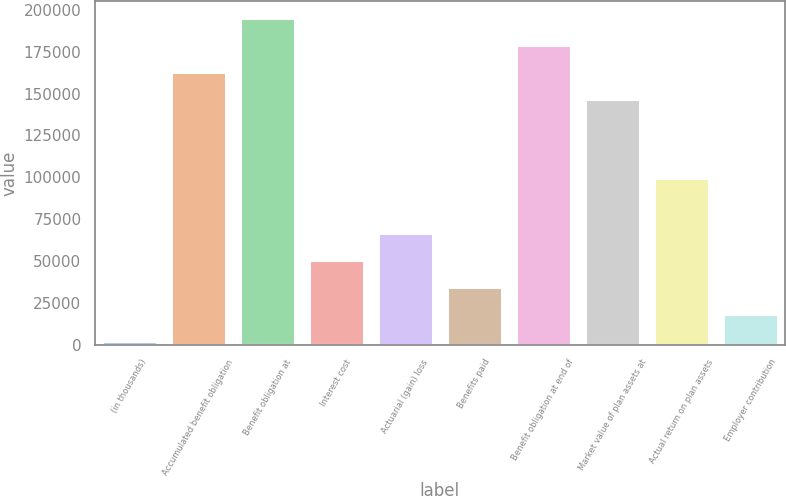Convert chart. <chart><loc_0><loc_0><loc_500><loc_500><bar_chart><fcel>(in thousands)<fcel>Accumulated benefit obligation<fcel>Benefit obligation at<fcel>Interest cost<fcel>Actuarial (gain) loss<fcel>Benefits paid<fcel>Benefit obligation at end of<fcel>Market value of plan assets at<fcel>Actual return on plan assets<fcel>Employer contribution<nl><fcel>2007<fcel>162885<fcel>195350<fcel>50705.4<fcel>66938.2<fcel>34472.6<fcel>179118<fcel>146652<fcel>99403.8<fcel>18239.8<nl></chart> 